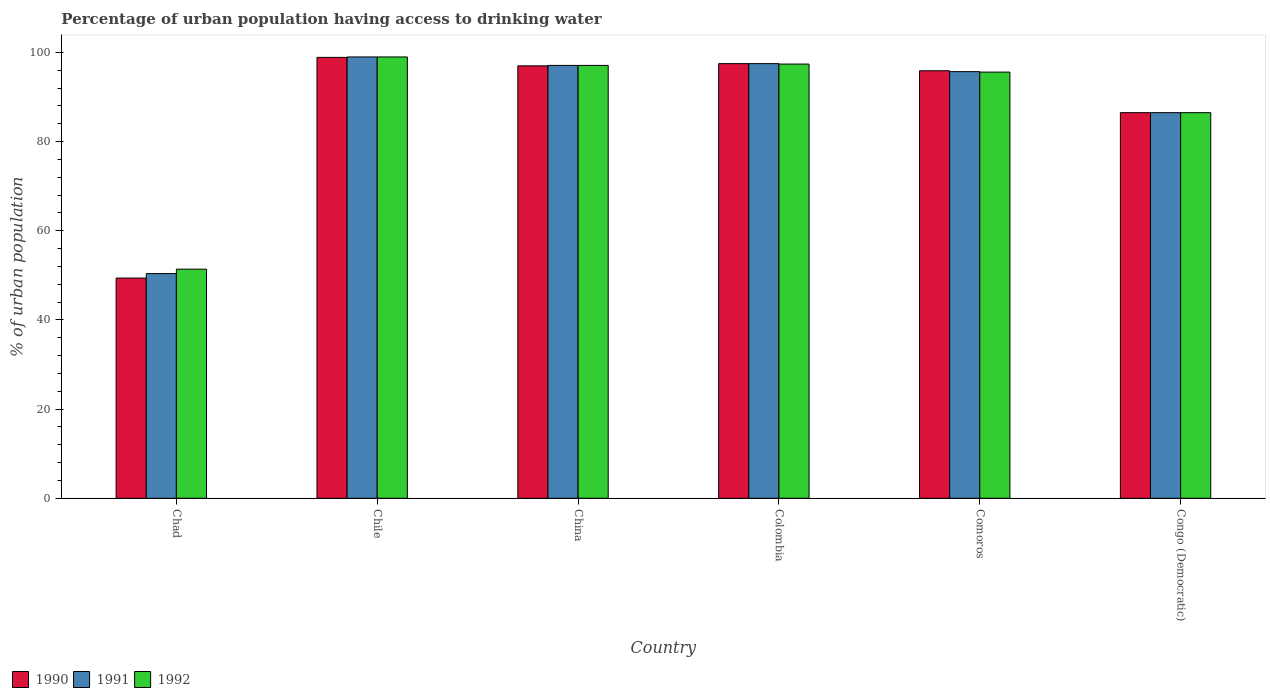How many different coloured bars are there?
Offer a terse response. 3. Are the number of bars per tick equal to the number of legend labels?
Provide a succinct answer. Yes. Are the number of bars on each tick of the X-axis equal?
Provide a short and direct response. Yes. How many bars are there on the 2nd tick from the left?
Your response must be concise. 3. How many bars are there on the 2nd tick from the right?
Offer a very short reply. 3. What is the percentage of urban population having access to drinking water in 1990 in Chile?
Provide a short and direct response. 98.9. Across all countries, what is the minimum percentage of urban population having access to drinking water in 1991?
Keep it short and to the point. 50.4. In which country was the percentage of urban population having access to drinking water in 1992 maximum?
Ensure brevity in your answer.  Chile. In which country was the percentage of urban population having access to drinking water in 1992 minimum?
Provide a short and direct response. Chad. What is the total percentage of urban population having access to drinking water in 1991 in the graph?
Your answer should be compact. 526.2. What is the difference between the percentage of urban population having access to drinking water in 1991 in Chad and that in Congo (Democratic)?
Offer a terse response. -36.1. What is the difference between the percentage of urban population having access to drinking water in 1990 in Comoros and the percentage of urban population having access to drinking water in 1992 in Chad?
Provide a short and direct response. 44.5. What is the average percentage of urban population having access to drinking water in 1990 per country?
Your response must be concise. 87.53. What is the difference between the percentage of urban population having access to drinking water of/in 1992 and percentage of urban population having access to drinking water of/in 1991 in China?
Ensure brevity in your answer.  0. In how many countries, is the percentage of urban population having access to drinking water in 1992 greater than 80 %?
Provide a succinct answer. 5. What is the ratio of the percentage of urban population having access to drinking water in 1990 in China to that in Colombia?
Provide a short and direct response. 0.99. What is the difference between the highest and the lowest percentage of urban population having access to drinking water in 1991?
Your response must be concise. 48.6. In how many countries, is the percentage of urban population having access to drinking water in 1991 greater than the average percentage of urban population having access to drinking water in 1991 taken over all countries?
Provide a succinct answer. 4. What does the 2nd bar from the right in Congo (Democratic) represents?
Your response must be concise. 1991. Is it the case that in every country, the sum of the percentage of urban population having access to drinking water in 1991 and percentage of urban population having access to drinking water in 1990 is greater than the percentage of urban population having access to drinking water in 1992?
Make the answer very short. Yes. How many countries are there in the graph?
Give a very brief answer. 6. What is the difference between two consecutive major ticks on the Y-axis?
Your answer should be very brief. 20. Are the values on the major ticks of Y-axis written in scientific E-notation?
Your answer should be compact. No. Does the graph contain any zero values?
Offer a terse response. No. Does the graph contain grids?
Provide a succinct answer. No. Where does the legend appear in the graph?
Ensure brevity in your answer.  Bottom left. How are the legend labels stacked?
Provide a succinct answer. Horizontal. What is the title of the graph?
Offer a terse response. Percentage of urban population having access to drinking water. What is the label or title of the Y-axis?
Keep it short and to the point. % of urban population. What is the % of urban population of 1990 in Chad?
Provide a succinct answer. 49.4. What is the % of urban population in 1991 in Chad?
Give a very brief answer. 50.4. What is the % of urban population in 1992 in Chad?
Give a very brief answer. 51.4. What is the % of urban population in 1990 in Chile?
Ensure brevity in your answer.  98.9. What is the % of urban population in 1992 in Chile?
Make the answer very short. 99. What is the % of urban population in 1990 in China?
Ensure brevity in your answer.  97. What is the % of urban population in 1991 in China?
Make the answer very short. 97.1. What is the % of urban population in 1992 in China?
Offer a terse response. 97.1. What is the % of urban population of 1990 in Colombia?
Make the answer very short. 97.5. What is the % of urban population of 1991 in Colombia?
Give a very brief answer. 97.5. What is the % of urban population of 1992 in Colombia?
Offer a very short reply. 97.4. What is the % of urban population of 1990 in Comoros?
Give a very brief answer. 95.9. What is the % of urban population in 1991 in Comoros?
Offer a very short reply. 95.7. What is the % of urban population in 1992 in Comoros?
Make the answer very short. 95.6. What is the % of urban population in 1990 in Congo (Democratic)?
Ensure brevity in your answer.  86.5. What is the % of urban population in 1991 in Congo (Democratic)?
Your answer should be compact. 86.5. What is the % of urban population of 1992 in Congo (Democratic)?
Your answer should be compact. 86.5. Across all countries, what is the maximum % of urban population in 1990?
Your answer should be very brief. 98.9. Across all countries, what is the maximum % of urban population of 1991?
Offer a very short reply. 99. Across all countries, what is the maximum % of urban population of 1992?
Offer a terse response. 99. Across all countries, what is the minimum % of urban population of 1990?
Your answer should be very brief. 49.4. Across all countries, what is the minimum % of urban population of 1991?
Your answer should be compact. 50.4. Across all countries, what is the minimum % of urban population of 1992?
Ensure brevity in your answer.  51.4. What is the total % of urban population in 1990 in the graph?
Provide a succinct answer. 525.2. What is the total % of urban population of 1991 in the graph?
Keep it short and to the point. 526.2. What is the total % of urban population of 1992 in the graph?
Give a very brief answer. 527. What is the difference between the % of urban population of 1990 in Chad and that in Chile?
Your answer should be compact. -49.5. What is the difference between the % of urban population of 1991 in Chad and that in Chile?
Provide a succinct answer. -48.6. What is the difference between the % of urban population of 1992 in Chad and that in Chile?
Provide a short and direct response. -47.6. What is the difference between the % of urban population of 1990 in Chad and that in China?
Keep it short and to the point. -47.6. What is the difference between the % of urban population in 1991 in Chad and that in China?
Make the answer very short. -46.7. What is the difference between the % of urban population in 1992 in Chad and that in China?
Provide a succinct answer. -45.7. What is the difference between the % of urban population in 1990 in Chad and that in Colombia?
Make the answer very short. -48.1. What is the difference between the % of urban population of 1991 in Chad and that in Colombia?
Give a very brief answer. -47.1. What is the difference between the % of urban population in 1992 in Chad and that in Colombia?
Give a very brief answer. -46. What is the difference between the % of urban population in 1990 in Chad and that in Comoros?
Give a very brief answer. -46.5. What is the difference between the % of urban population in 1991 in Chad and that in Comoros?
Keep it short and to the point. -45.3. What is the difference between the % of urban population of 1992 in Chad and that in Comoros?
Offer a very short reply. -44.2. What is the difference between the % of urban population in 1990 in Chad and that in Congo (Democratic)?
Offer a very short reply. -37.1. What is the difference between the % of urban population of 1991 in Chad and that in Congo (Democratic)?
Make the answer very short. -36.1. What is the difference between the % of urban population of 1992 in Chad and that in Congo (Democratic)?
Offer a terse response. -35.1. What is the difference between the % of urban population of 1990 in Chile and that in China?
Give a very brief answer. 1.9. What is the difference between the % of urban population of 1991 in Chile and that in China?
Your answer should be very brief. 1.9. What is the difference between the % of urban population in 1991 in Chile and that in Colombia?
Provide a succinct answer. 1.5. What is the difference between the % of urban population of 1990 in Chile and that in Congo (Democratic)?
Provide a short and direct response. 12.4. What is the difference between the % of urban population of 1991 in Chile and that in Congo (Democratic)?
Provide a succinct answer. 12.5. What is the difference between the % of urban population in 1990 in China and that in Colombia?
Ensure brevity in your answer.  -0.5. What is the difference between the % of urban population of 1991 in China and that in Colombia?
Your response must be concise. -0.4. What is the difference between the % of urban population in 1990 in China and that in Comoros?
Keep it short and to the point. 1.1. What is the difference between the % of urban population of 1991 in China and that in Comoros?
Your response must be concise. 1.4. What is the difference between the % of urban population of 1991 in China and that in Congo (Democratic)?
Make the answer very short. 10.6. What is the difference between the % of urban population in 1992 in China and that in Congo (Democratic)?
Give a very brief answer. 10.6. What is the difference between the % of urban population of 1990 in Colombia and that in Comoros?
Offer a very short reply. 1.6. What is the difference between the % of urban population in 1991 in Colombia and that in Comoros?
Your response must be concise. 1.8. What is the difference between the % of urban population in 1991 in Colombia and that in Congo (Democratic)?
Your answer should be compact. 11. What is the difference between the % of urban population of 1992 in Colombia and that in Congo (Democratic)?
Keep it short and to the point. 10.9. What is the difference between the % of urban population of 1991 in Comoros and that in Congo (Democratic)?
Provide a short and direct response. 9.2. What is the difference between the % of urban population in 1990 in Chad and the % of urban population in 1991 in Chile?
Provide a short and direct response. -49.6. What is the difference between the % of urban population in 1990 in Chad and the % of urban population in 1992 in Chile?
Your answer should be very brief. -49.6. What is the difference between the % of urban population of 1991 in Chad and the % of urban population of 1992 in Chile?
Give a very brief answer. -48.6. What is the difference between the % of urban population in 1990 in Chad and the % of urban population in 1991 in China?
Keep it short and to the point. -47.7. What is the difference between the % of urban population in 1990 in Chad and the % of urban population in 1992 in China?
Your answer should be very brief. -47.7. What is the difference between the % of urban population in 1991 in Chad and the % of urban population in 1992 in China?
Provide a succinct answer. -46.7. What is the difference between the % of urban population in 1990 in Chad and the % of urban population in 1991 in Colombia?
Provide a short and direct response. -48.1. What is the difference between the % of urban population in 1990 in Chad and the % of urban population in 1992 in Colombia?
Provide a succinct answer. -48. What is the difference between the % of urban population of 1991 in Chad and the % of urban population of 1992 in Colombia?
Provide a short and direct response. -47. What is the difference between the % of urban population in 1990 in Chad and the % of urban population in 1991 in Comoros?
Make the answer very short. -46.3. What is the difference between the % of urban population in 1990 in Chad and the % of urban population in 1992 in Comoros?
Your answer should be compact. -46.2. What is the difference between the % of urban population of 1991 in Chad and the % of urban population of 1992 in Comoros?
Offer a very short reply. -45.2. What is the difference between the % of urban population of 1990 in Chad and the % of urban population of 1991 in Congo (Democratic)?
Your response must be concise. -37.1. What is the difference between the % of urban population of 1990 in Chad and the % of urban population of 1992 in Congo (Democratic)?
Give a very brief answer. -37.1. What is the difference between the % of urban population of 1991 in Chad and the % of urban population of 1992 in Congo (Democratic)?
Your response must be concise. -36.1. What is the difference between the % of urban population of 1990 in Chile and the % of urban population of 1991 in China?
Give a very brief answer. 1.8. What is the difference between the % of urban population of 1990 in Chile and the % of urban population of 1992 in China?
Your response must be concise. 1.8. What is the difference between the % of urban population in 1990 in Chile and the % of urban population in 1991 in Colombia?
Make the answer very short. 1.4. What is the difference between the % of urban population of 1990 in Chile and the % of urban population of 1992 in Colombia?
Provide a short and direct response. 1.5. What is the difference between the % of urban population of 1991 in Chile and the % of urban population of 1992 in Colombia?
Keep it short and to the point. 1.6. What is the difference between the % of urban population in 1990 in Chile and the % of urban population in 1992 in Comoros?
Provide a succinct answer. 3.3. What is the difference between the % of urban population in 1990 in Chile and the % of urban population in 1992 in Congo (Democratic)?
Offer a terse response. 12.4. What is the difference between the % of urban population in 1991 in China and the % of urban population in 1992 in Colombia?
Offer a very short reply. -0.3. What is the difference between the % of urban population in 1991 in China and the % of urban population in 1992 in Congo (Democratic)?
Your answer should be very brief. 10.6. What is the difference between the % of urban population of 1991 in Colombia and the % of urban population of 1992 in Comoros?
Offer a terse response. 1.9. What is the difference between the % of urban population in 1990 in Colombia and the % of urban population in 1992 in Congo (Democratic)?
Offer a terse response. 11. What is the difference between the % of urban population in 1991 in Colombia and the % of urban population in 1992 in Congo (Democratic)?
Keep it short and to the point. 11. What is the difference between the % of urban population of 1990 in Comoros and the % of urban population of 1991 in Congo (Democratic)?
Give a very brief answer. 9.4. What is the difference between the % of urban population in 1990 in Comoros and the % of urban population in 1992 in Congo (Democratic)?
Your response must be concise. 9.4. What is the difference between the % of urban population in 1991 in Comoros and the % of urban population in 1992 in Congo (Democratic)?
Provide a short and direct response. 9.2. What is the average % of urban population in 1990 per country?
Ensure brevity in your answer.  87.53. What is the average % of urban population in 1991 per country?
Offer a terse response. 87.7. What is the average % of urban population in 1992 per country?
Ensure brevity in your answer.  87.83. What is the difference between the % of urban population in 1990 and % of urban population in 1992 in Chad?
Your response must be concise. -2. What is the difference between the % of urban population of 1990 and % of urban population of 1991 in Chile?
Your answer should be very brief. -0.1. What is the difference between the % of urban population in 1990 and % of urban population in 1992 in Chile?
Offer a very short reply. -0.1. What is the difference between the % of urban population in 1991 and % of urban population in 1992 in Chile?
Your answer should be very brief. 0. What is the difference between the % of urban population in 1991 and % of urban population in 1992 in China?
Your response must be concise. 0. What is the difference between the % of urban population in 1990 and % of urban population in 1992 in Colombia?
Ensure brevity in your answer.  0.1. What is the difference between the % of urban population of 1990 and % of urban population of 1991 in Comoros?
Your answer should be very brief. 0.2. What is the difference between the % of urban population of 1990 and % of urban population of 1992 in Comoros?
Ensure brevity in your answer.  0.3. What is the difference between the % of urban population of 1991 and % of urban population of 1992 in Comoros?
Make the answer very short. 0.1. What is the difference between the % of urban population in 1990 and % of urban population in 1991 in Congo (Democratic)?
Provide a succinct answer. 0. What is the difference between the % of urban population in 1991 and % of urban population in 1992 in Congo (Democratic)?
Keep it short and to the point. 0. What is the ratio of the % of urban population in 1990 in Chad to that in Chile?
Your answer should be compact. 0.5. What is the ratio of the % of urban population in 1991 in Chad to that in Chile?
Ensure brevity in your answer.  0.51. What is the ratio of the % of urban population in 1992 in Chad to that in Chile?
Provide a succinct answer. 0.52. What is the ratio of the % of urban population of 1990 in Chad to that in China?
Keep it short and to the point. 0.51. What is the ratio of the % of urban population in 1991 in Chad to that in China?
Your answer should be compact. 0.52. What is the ratio of the % of urban population in 1992 in Chad to that in China?
Your answer should be compact. 0.53. What is the ratio of the % of urban population of 1990 in Chad to that in Colombia?
Make the answer very short. 0.51. What is the ratio of the % of urban population in 1991 in Chad to that in Colombia?
Ensure brevity in your answer.  0.52. What is the ratio of the % of urban population in 1992 in Chad to that in Colombia?
Your answer should be compact. 0.53. What is the ratio of the % of urban population of 1990 in Chad to that in Comoros?
Provide a succinct answer. 0.52. What is the ratio of the % of urban population in 1991 in Chad to that in Comoros?
Offer a very short reply. 0.53. What is the ratio of the % of urban population in 1992 in Chad to that in Comoros?
Make the answer very short. 0.54. What is the ratio of the % of urban population in 1990 in Chad to that in Congo (Democratic)?
Offer a terse response. 0.57. What is the ratio of the % of urban population in 1991 in Chad to that in Congo (Democratic)?
Offer a terse response. 0.58. What is the ratio of the % of urban population in 1992 in Chad to that in Congo (Democratic)?
Your response must be concise. 0.59. What is the ratio of the % of urban population in 1990 in Chile to that in China?
Your response must be concise. 1.02. What is the ratio of the % of urban population in 1991 in Chile to that in China?
Your answer should be very brief. 1.02. What is the ratio of the % of urban population in 1992 in Chile to that in China?
Ensure brevity in your answer.  1.02. What is the ratio of the % of urban population in 1990 in Chile to that in Colombia?
Your answer should be very brief. 1.01. What is the ratio of the % of urban population of 1991 in Chile to that in Colombia?
Your response must be concise. 1.02. What is the ratio of the % of urban population of 1992 in Chile to that in Colombia?
Keep it short and to the point. 1.02. What is the ratio of the % of urban population of 1990 in Chile to that in Comoros?
Make the answer very short. 1.03. What is the ratio of the % of urban population of 1991 in Chile to that in Comoros?
Keep it short and to the point. 1.03. What is the ratio of the % of urban population of 1992 in Chile to that in Comoros?
Give a very brief answer. 1.04. What is the ratio of the % of urban population in 1990 in Chile to that in Congo (Democratic)?
Your answer should be compact. 1.14. What is the ratio of the % of urban population of 1991 in Chile to that in Congo (Democratic)?
Make the answer very short. 1.14. What is the ratio of the % of urban population of 1992 in Chile to that in Congo (Democratic)?
Give a very brief answer. 1.14. What is the ratio of the % of urban population of 1990 in China to that in Comoros?
Give a very brief answer. 1.01. What is the ratio of the % of urban population in 1991 in China to that in Comoros?
Provide a succinct answer. 1.01. What is the ratio of the % of urban population in 1992 in China to that in Comoros?
Provide a short and direct response. 1.02. What is the ratio of the % of urban population of 1990 in China to that in Congo (Democratic)?
Make the answer very short. 1.12. What is the ratio of the % of urban population of 1991 in China to that in Congo (Democratic)?
Give a very brief answer. 1.12. What is the ratio of the % of urban population of 1992 in China to that in Congo (Democratic)?
Make the answer very short. 1.12. What is the ratio of the % of urban population of 1990 in Colombia to that in Comoros?
Offer a very short reply. 1.02. What is the ratio of the % of urban population of 1991 in Colombia to that in Comoros?
Give a very brief answer. 1.02. What is the ratio of the % of urban population of 1992 in Colombia to that in Comoros?
Offer a very short reply. 1.02. What is the ratio of the % of urban population in 1990 in Colombia to that in Congo (Democratic)?
Provide a short and direct response. 1.13. What is the ratio of the % of urban population in 1991 in Colombia to that in Congo (Democratic)?
Offer a terse response. 1.13. What is the ratio of the % of urban population of 1992 in Colombia to that in Congo (Democratic)?
Give a very brief answer. 1.13. What is the ratio of the % of urban population of 1990 in Comoros to that in Congo (Democratic)?
Your answer should be compact. 1.11. What is the ratio of the % of urban population in 1991 in Comoros to that in Congo (Democratic)?
Offer a very short reply. 1.11. What is the ratio of the % of urban population of 1992 in Comoros to that in Congo (Democratic)?
Ensure brevity in your answer.  1.11. What is the difference between the highest and the second highest % of urban population in 1990?
Offer a very short reply. 1.4. What is the difference between the highest and the second highest % of urban population in 1991?
Ensure brevity in your answer.  1.5. What is the difference between the highest and the second highest % of urban population in 1992?
Your answer should be compact. 1.6. What is the difference between the highest and the lowest % of urban population in 1990?
Keep it short and to the point. 49.5. What is the difference between the highest and the lowest % of urban population in 1991?
Offer a terse response. 48.6. What is the difference between the highest and the lowest % of urban population of 1992?
Your answer should be compact. 47.6. 